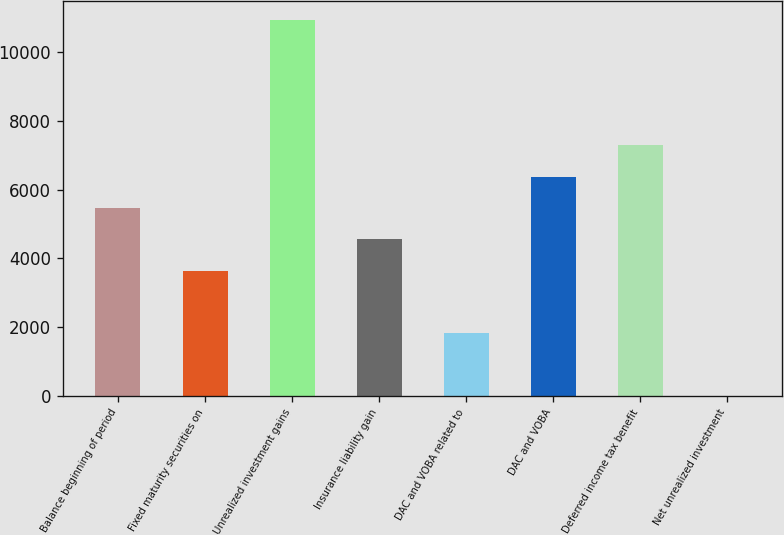<chart> <loc_0><loc_0><loc_500><loc_500><bar_chart><fcel>Balance beginning of period<fcel>Fixed maturity securities on<fcel>Unrealized investment gains<fcel>Insurance liability gain<fcel>DAC and VOBA related to<fcel>DAC and VOBA<fcel>Deferred income tax benefit<fcel>Net unrealized investment<nl><fcel>5471.4<fcel>3648.6<fcel>10939.8<fcel>4560<fcel>1825.8<fcel>6382.8<fcel>7294.2<fcel>3<nl></chart> 